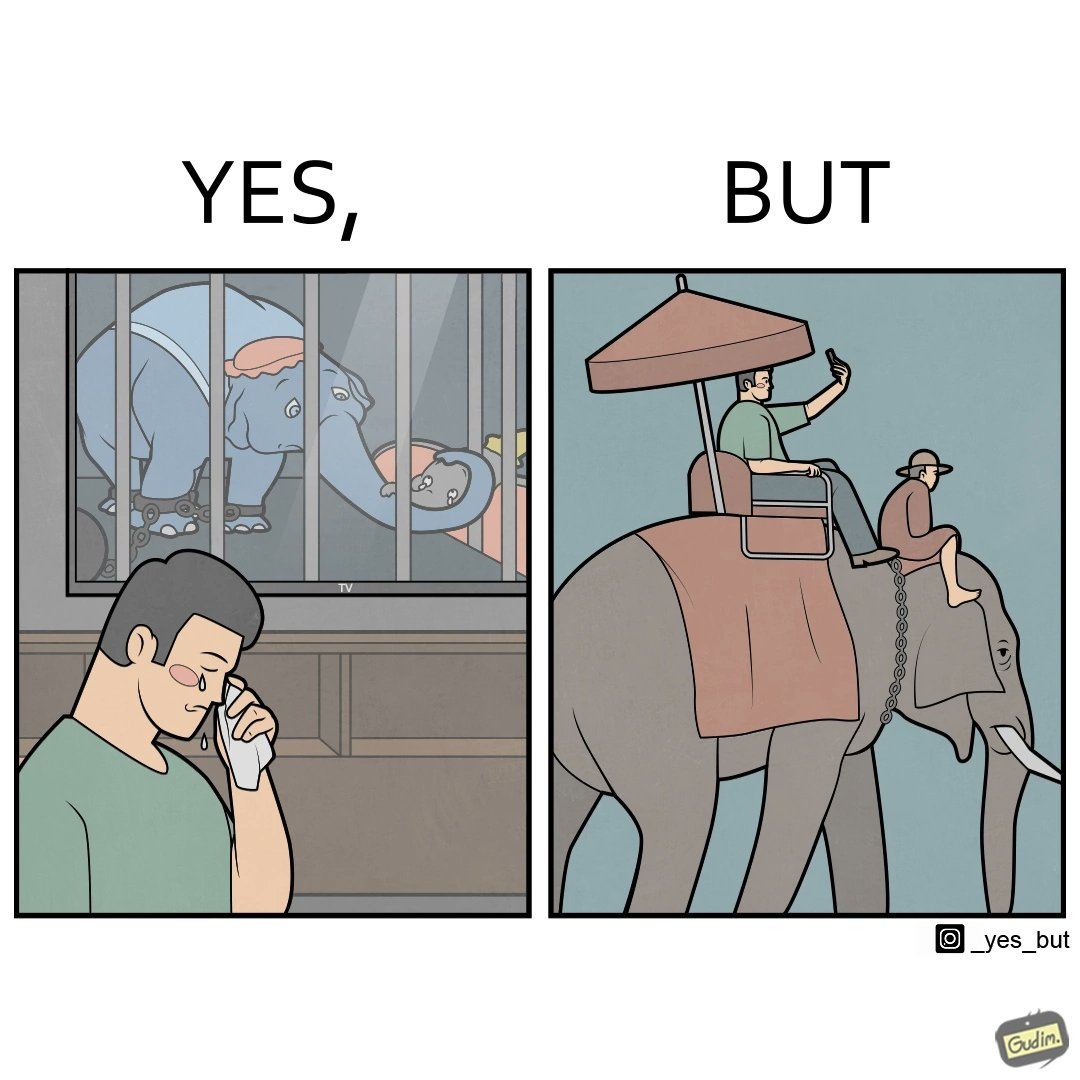What makes this image funny or satirical? The image is ironic, because the people who get sentimental over imprisoned animal while watching TV shows often feel okay when using animals for labor 